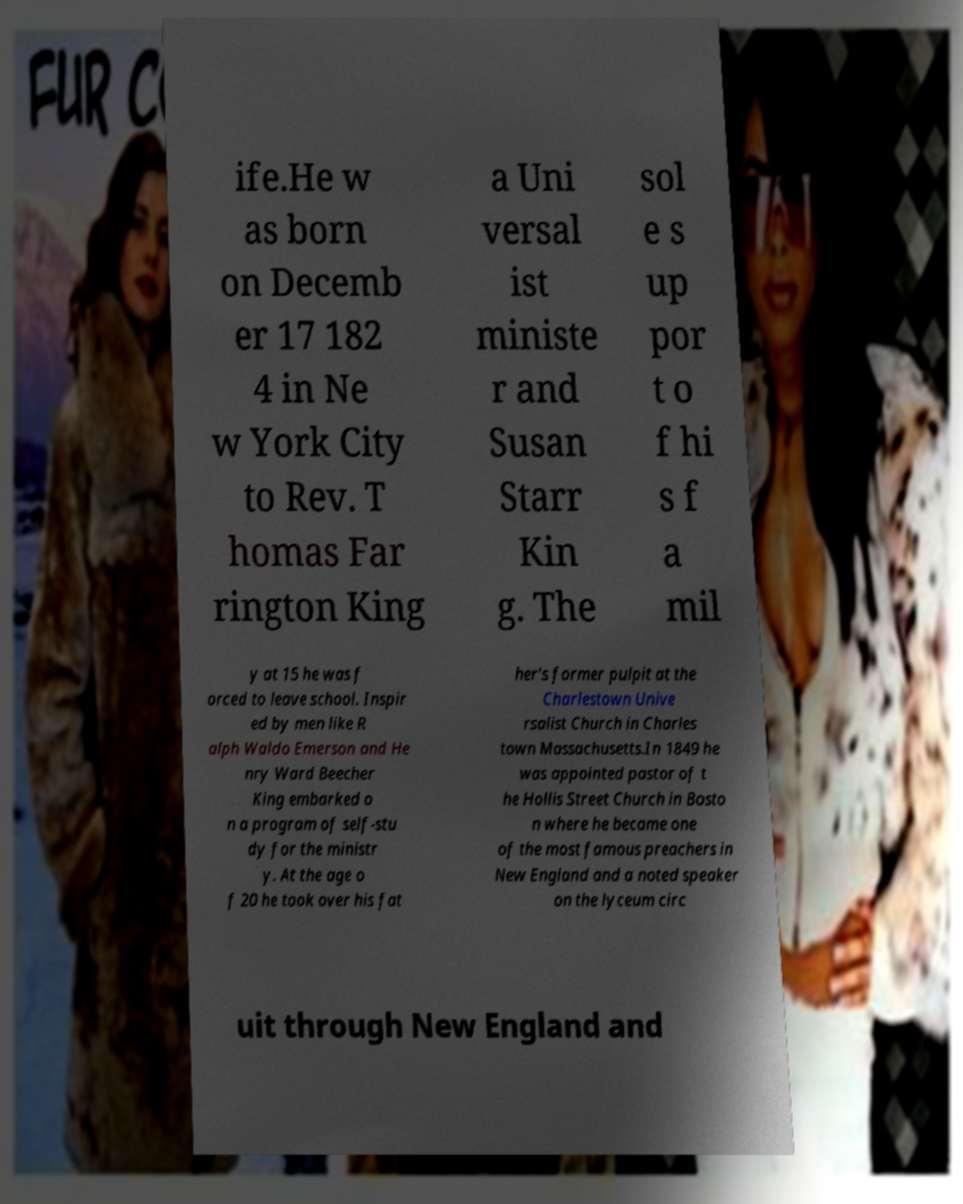Could you extract and type out the text from this image? ife.He w as born on Decemb er 17 182 4 in Ne w York City to Rev. T homas Far rington King a Uni versal ist ministe r and Susan Starr Kin g. The sol e s up por t o f hi s f a mil y at 15 he was f orced to leave school. Inspir ed by men like R alph Waldo Emerson and He nry Ward Beecher King embarked o n a program of self-stu dy for the ministr y. At the age o f 20 he took over his fat her's former pulpit at the Charlestown Unive rsalist Church in Charles town Massachusetts.In 1849 he was appointed pastor of t he Hollis Street Church in Bosto n where he became one of the most famous preachers in New England and a noted speaker on the lyceum circ uit through New England and 